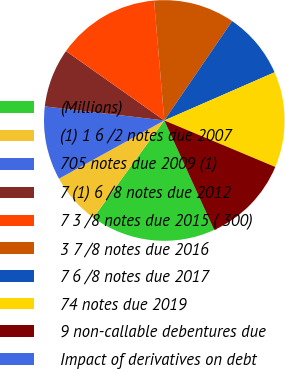Convert chart. <chart><loc_0><loc_0><loc_500><loc_500><pie_chart><fcel>(Millions)<fcel>(1) 1 6 /2 notes due 2007<fcel>705 notes due 2009 (1)<fcel>7 (1) 6 /8 notes due 2012<fcel>7 3 /8 notes due 2015 ( 300)<fcel>3 7 /8 notes due 2016<fcel>7 6 /8 notes due 2017<fcel>74 notes due 2019<fcel>9 non-callable debentures due<fcel>Impact of derivatives on debt<nl><fcel>16.83%<fcel>6.93%<fcel>9.9%<fcel>7.92%<fcel>13.86%<fcel>10.89%<fcel>8.91%<fcel>12.87%<fcel>11.88%<fcel>0.0%<nl></chart> 